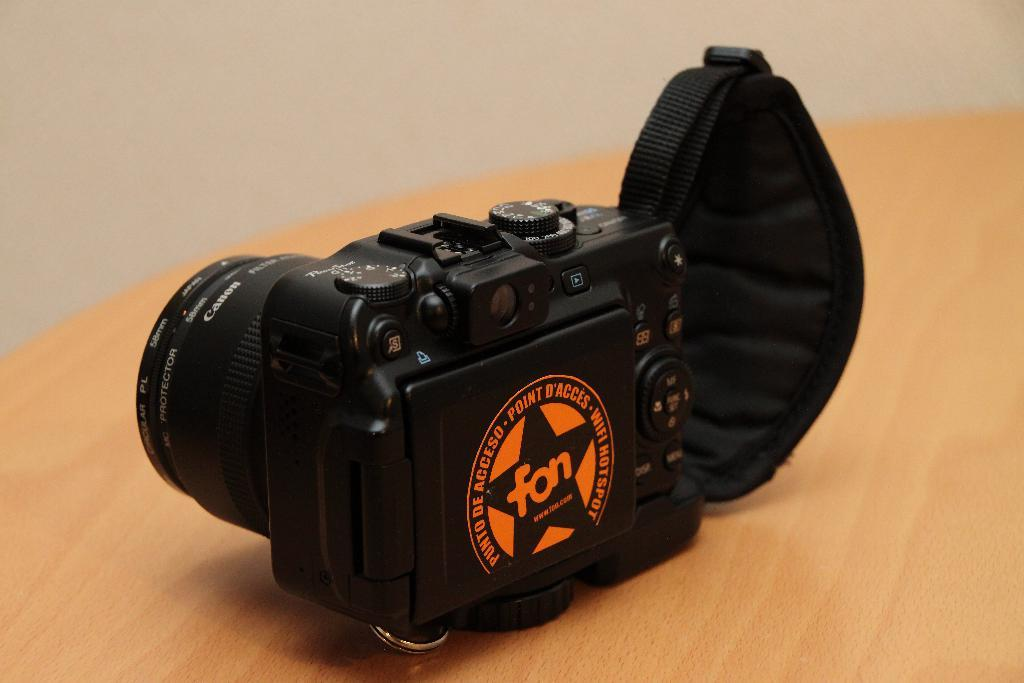What object is the main subject of the image? There is a camera in the image. Where is the camera located? The camera is on a table. Can you describe the background of the image? The background of the image is blurred. What type of railway can be seen in the image? There is no railway present in the image. Is there a flame visible in the image? There is no flame visible in the image. Can you see any animals in the image? There is no zoo or any animals present in the image. 